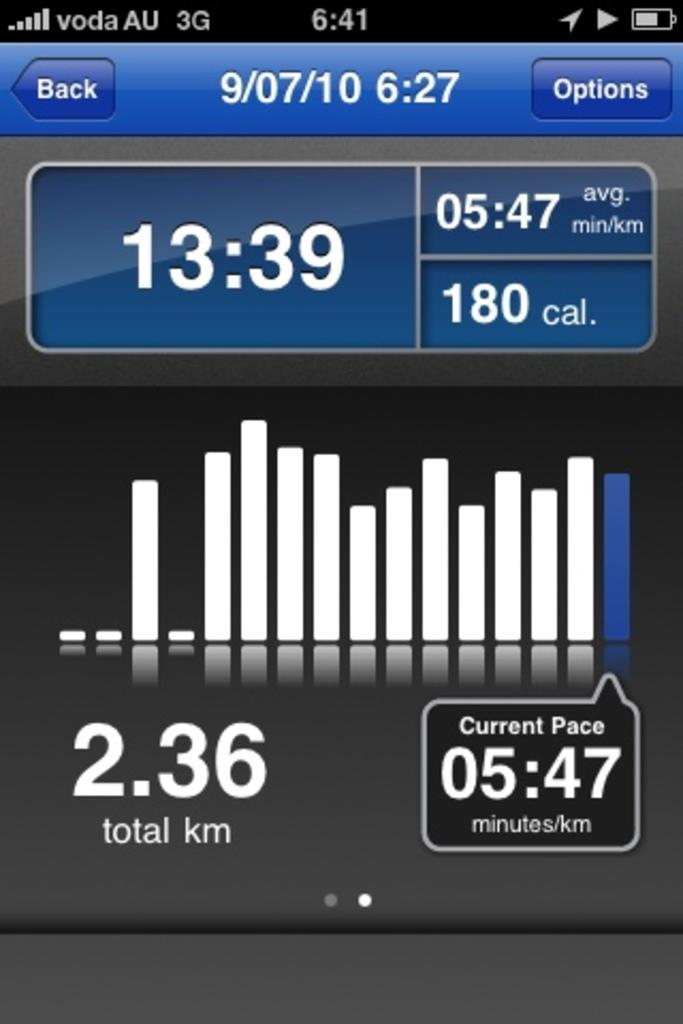Provide a one-sentence caption for the provided image. A phone screen shows an app that shows 2.36 total km and a current pace of 05:47 minutes per km. 